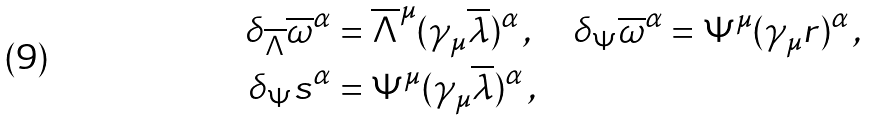<formula> <loc_0><loc_0><loc_500><loc_500>\delta _ { \overline { \Lambda } } \overline { \omega } ^ { \alpha } & = \overline { \Lambda } ^ { \mu } ( \gamma _ { \mu } \overline { \lambda } ) ^ { \alpha } \, , \quad \delta _ { \Psi } \overline { \omega } ^ { \alpha } = \Psi ^ { \mu } ( \gamma _ { \mu } r ) ^ { \alpha } \, , \\ \delta _ { \Psi } s ^ { \alpha } & = \Psi ^ { \mu } ( \gamma _ { \mu } \overline { \lambda } ) ^ { \alpha } \, ,</formula> 